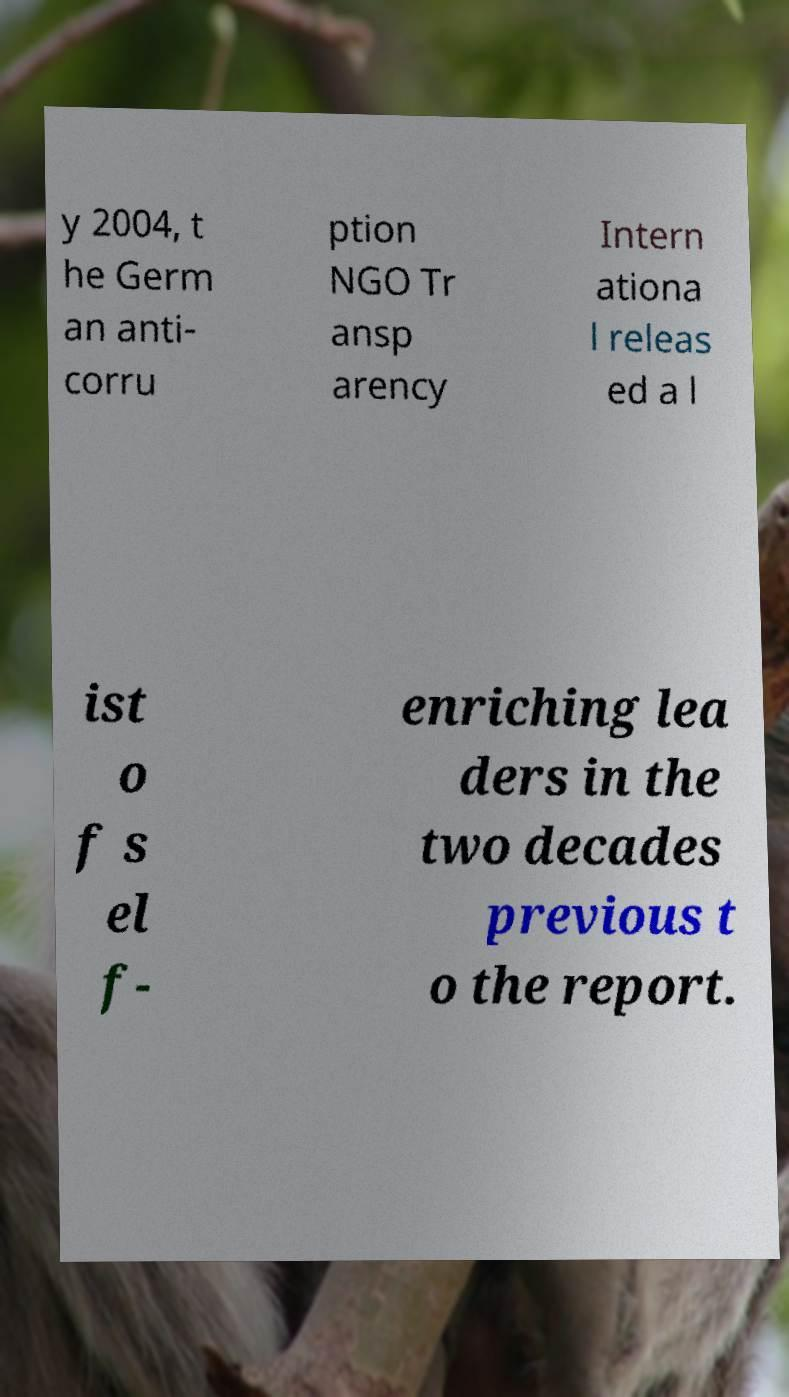There's text embedded in this image that I need extracted. Can you transcribe it verbatim? y 2004, t he Germ an anti- corru ption NGO Tr ansp arency Intern ationa l releas ed a l ist o f s el f- enriching lea ders in the two decades previous t o the report. 